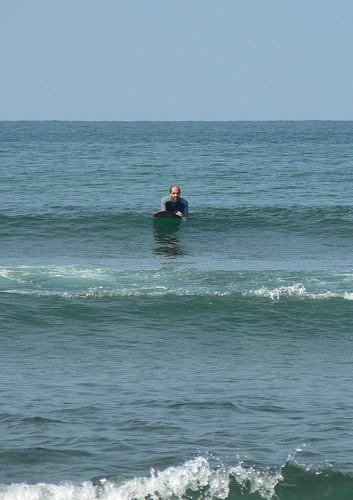Question: what gender is the person in the photo?
Choices:
A. Female.
B. Male.
C. Transgender.
D. Homosexual.
Answer with the letter. Answer: B Question: how many people are in the photo?
Choices:
A. Two.
B. One.
C. Three.
D. Four.
Answer with the letter. Answer: B Question: what is the man doing?
Choices:
A. Swimming.
B. Running.
C. Surfing.
D. Eating.
Answer with the letter. Answer: C Question: what is the man on?
Choices:
A. A surfboard.
B. A ski board.
C. Roller skates.
D. A bicycle.
Answer with the letter. Answer: A Question: what are in the water?
Choices:
A. Boats.
B. People.
C. Waves.
D. Dolphins.
Answer with the letter. Answer: C 